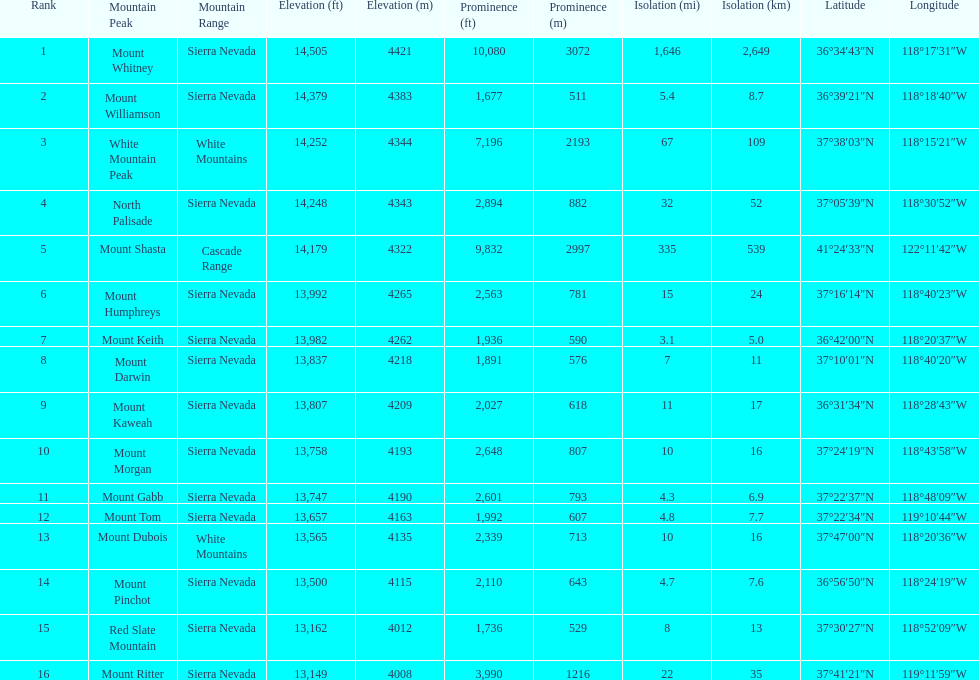What is the next highest mountain peak after north palisade? Mount Shasta. 